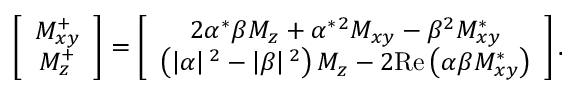Convert formula to latex. <formula><loc_0><loc_0><loc_500><loc_500>\left [ \begin{array} { c } { M _ { x y } ^ { + } } \\ { M _ { z } ^ { + } } \end{array} \right ] = \left [ \begin{array} { c } { 2 \alpha ^ { * } \beta M _ { z } + \alpha ^ { * } ^ { 2 } } M _ { x y } - \beta ^ { 2 } } M _ { x y } ^ { * } } \\ { \left ( \left | \alpha \right | ^ { 2 } } - \left | \beta \right | ^ { 2 } } \right ) M _ { z } - 2 R e \left ( \alpha \beta M _ { x y } ^ { * } \right ) } \end{array} \right ] .</formula> 